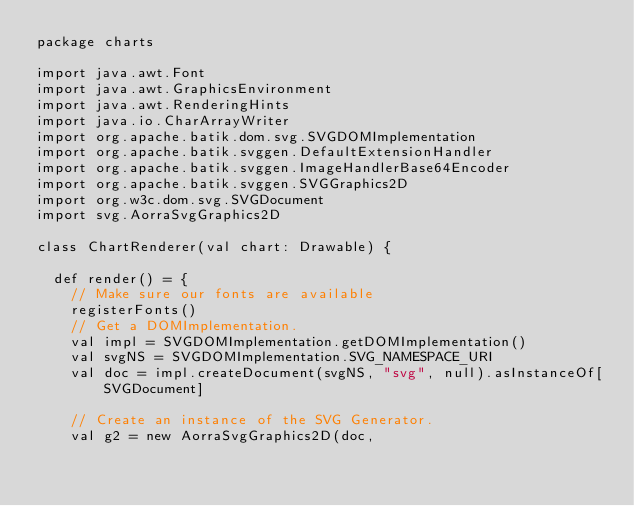<code> <loc_0><loc_0><loc_500><loc_500><_Scala_>package charts

import java.awt.Font
import java.awt.GraphicsEnvironment
import java.awt.RenderingHints
import java.io.CharArrayWriter
import org.apache.batik.dom.svg.SVGDOMImplementation
import org.apache.batik.svggen.DefaultExtensionHandler
import org.apache.batik.svggen.ImageHandlerBase64Encoder
import org.apache.batik.svggen.SVGGraphics2D
import org.w3c.dom.svg.SVGDocument
import svg.AorraSvgGraphics2D

class ChartRenderer(val chart: Drawable) {

  def render() = {
    // Make sure our fonts are available
    registerFonts()
    // Get a DOMImplementation.
    val impl = SVGDOMImplementation.getDOMImplementation()
    val svgNS = SVGDOMImplementation.SVG_NAMESPACE_URI
    val doc = impl.createDocument(svgNS, "svg", null).asInstanceOf[SVGDocument]

    // Create an instance of the SVG Generator.
    val g2 = new AorraSvgGraphics2D(doc,</code> 